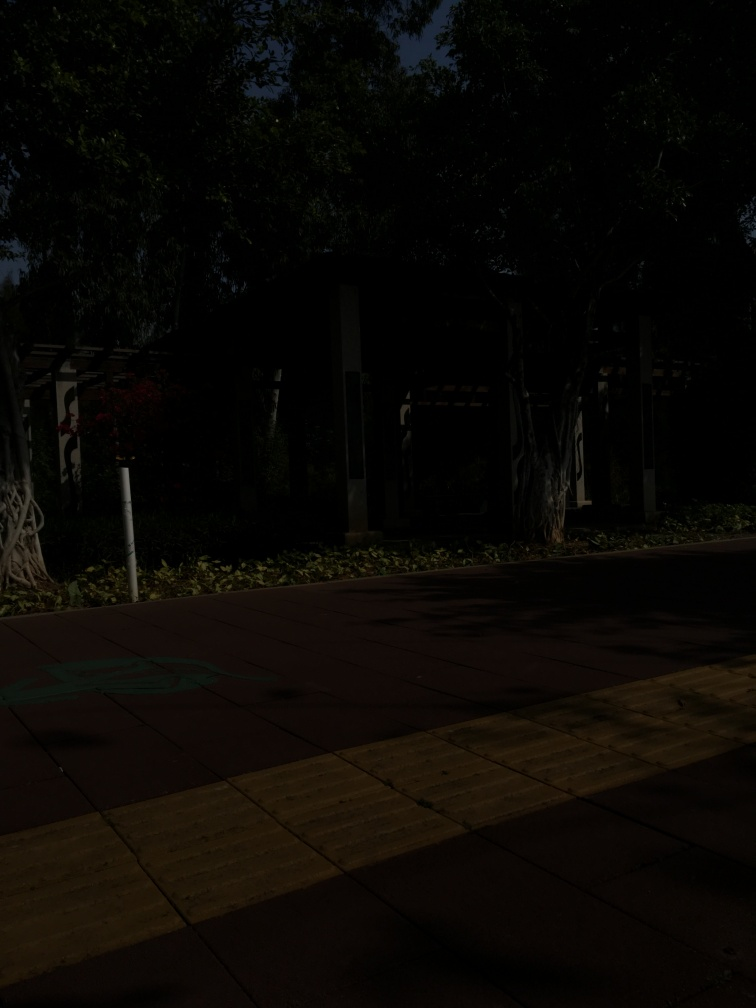What time of day does this image seem to depict? The image appears to capture a moment either in the early morning or late afternoon, as suggested by the subdued lighting and elongated shadows, indicating that the sun is low in the sky. What could be the function of the space shown in the image? The space seems to be a public area, likely a park or recreational area, designed for people to walk, sit, and enjoy the surrounding greenery. The presence of well-maintained sidewalks indicates it's a space meant for casual strolling or relaxation. 